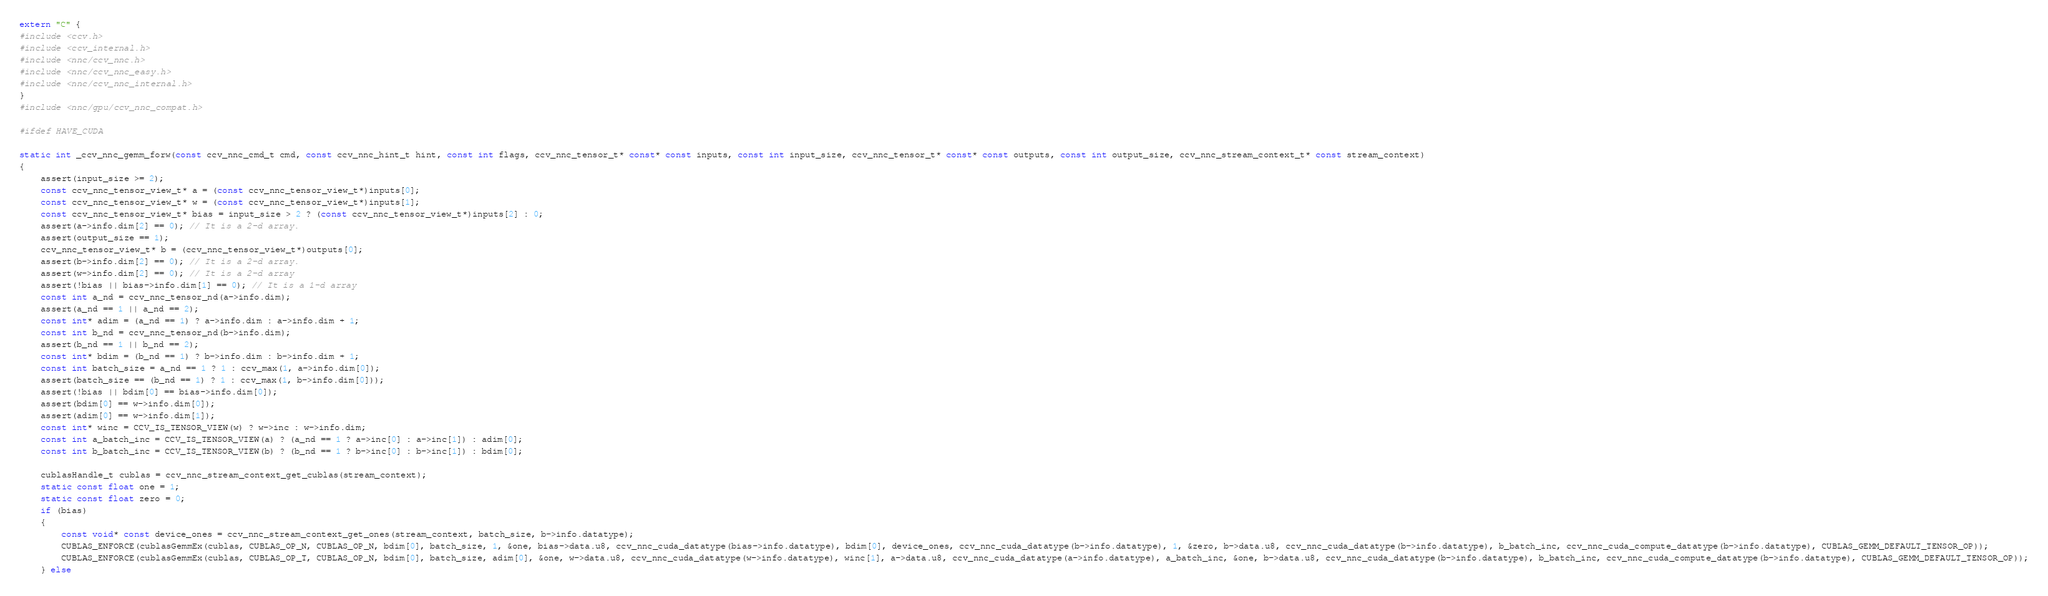Convert code to text. <code><loc_0><loc_0><loc_500><loc_500><_Cuda_>extern "C" {
#include <ccv.h>
#include <ccv_internal.h>
#include <nnc/ccv_nnc.h>
#include <nnc/ccv_nnc_easy.h>
#include <nnc/ccv_nnc_internal.h>
}
#include <nnc/gpu/ccv_nnc_compat.h>

#ifdef HAVE_CUDA

static int _ccv_nnc_gemm_forw(const ccv_nnc_cmd_t cmd, const ccv_nnc_hint_t hint, const int flags, ccv_nnc_tensor_t* const* const inputs, const int input_size, ccv_nnc_tensor_t* const* const outputs, const int output_size, ccv_nnc_stream_context_t* const stream_context)
{
	assert(input_size >= 2);
	const ccv_nnc_tensor_view_t* a = (const ccv_nnc_tensor_view_t*)inputs[0];
	const ccv_nnc_tensor_view_t* w = (const ccv_nnc_tensor_view_t*)inputs[1];
	const ccv_nnc_tensor_view_t* bias = input_size > 2 ? (const ccv_nnc_tensor_view_t*)inputs[2] : 0;
	assert(a->info.dim[2] == 0); // It is a 2-d array.
	assert(output_size == 1);
	ccv_nnc_tensor_view_t* b = (ccv_nnc_tensor_view_t*)outputs[0];
	assert(b->info.dim[2] == 0); // It is a 2-d array.
	assert(w->info.dim[2] == 0); // It is a 2-d array
	assert(!bias || bias->info.dim[1] == 0); // It is a 1-d array
	const int a_nd = ccv_nnc_tensor_nd(a->info.dim);
	assert(a_nd == 1 || a_nd == 2);
	const int* adim = (a_nd == 1) ? a->info.dim : a->info.dim + 1;
	const int b_nd = ccv_nnc_tensor_nd(b->info.dim);
	assert(b_nd == 1 || b_nd == 2);
	const int* bdim = (b_nd == 1) ? b->info.dim : b->info.dim + 1;
	const int batch_size = a_nd == 1 ? 1 : ccv_max(1, a->info.dim[0]);
	assert(batch_size == (b_nd == 1) ? 1 : ccv_max(1, b->info.dim[0]));
	assert(!bias || bdim[0] == bias->info.dim[0]);
	assert(bdim[0] == w->info.dim[0]);
	assert(adim[0] == w->info.dim[1]);
	const int* winc = CCV_IS_TENSOR_VIEW(w) ? w->inc : w->info.dim;
	const int a_batch_inc = CCV_IS_TENSOR_VIEW(a) ? (a_nd == 1 ? a->inc[0] : a->inc[1]) : adim[0];
	const int b_batch_inc = CCV_IS_TENSOR_VIEW(b) ? (b_nd == 1 ? b->inc[0] : b->inc[1]) : bdim[0];

	cublasHandle_t cublas = ccv_nnc_stream_context_get_cublas(stream_context);
	static const float one = 1;
	static const float zero = 0;
	if (bias)
	{
		const void* const device_ones = ccv_nnc_stream_context_get_ones(stream_context, batch_size, b->info.datatype);
		CUBLAS_ENFORCE(cublasGemmEx(cublas, CUBLAS_OP_N, CUBLAS_OP_N, bdim[0], batch_size, 1, &one, bias->data.u8, ccv_nnc_cuda_datatype(bias->info.datatype), bdim[0], device_ones, ccv_nnc_cuda_datatype(b->info.datatype), 1, &zero, b->data.u8, ccv_nnc_cuda_datatype(b->info.datatype), b_batch_inc, ccv_nnc_cuda_compute_datatype(b->info.datatype), CUBLAS_GEMM_DEFAULT_TENSOR_OP));
		CUBLAS_ENFORCE(cublasGemmEx(cublas, CUBLAS_OP_T, CUBLAS_OP_N, bdim[0], batch_size, adim[0], &one, w->data.u8, ccv_nnc_cuda_datatype(w->info.datatype), winc[1], a->data.u8, ccv_nnc_cuda_datatype(a->info.datatype), a_batch_inc, &one, b->data.u8, ccv_nnc_cuda_datatype(b->info.datatype), b_batch_inc, ccv_nnc_cuda_compute_datatype(b->info.datatype), CUBLAS_GEMM_DEFAULT_TENSOR_OP));
	} else</code> 